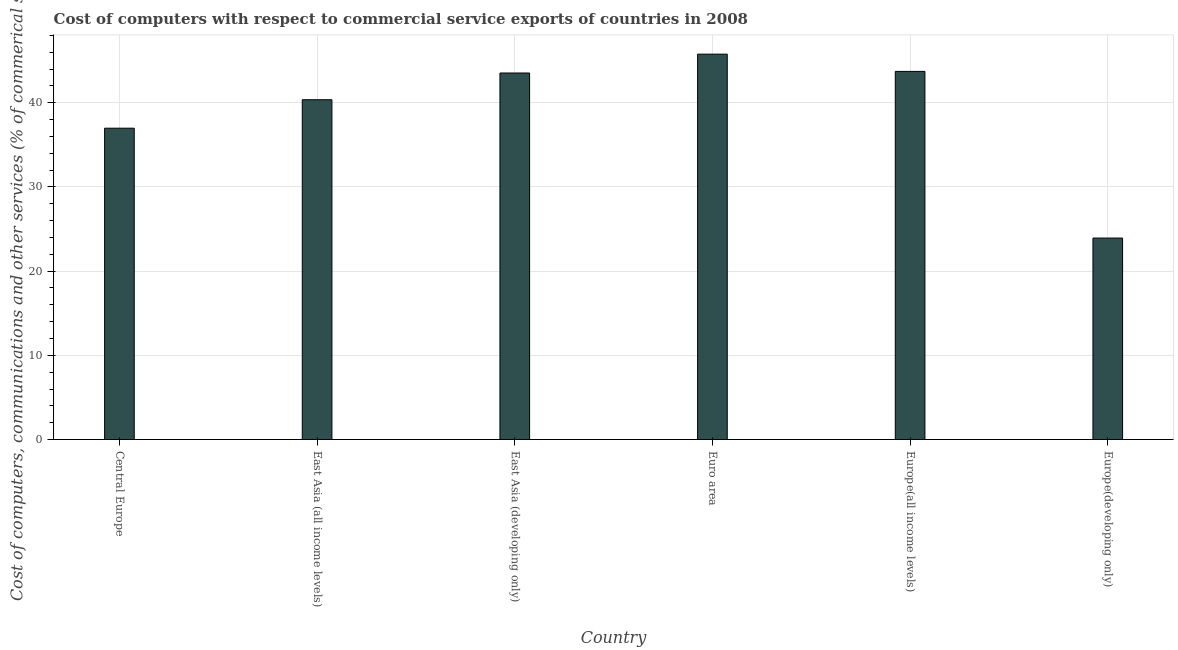Does the graph contain grids?
Give a very brief answer. Yes. What is the title of the graph?
Give a very brief answer. Cost of computers with respect to commercial service exports of countries in 2008. What is the label or title of the X-axis?
Offer a very short reply. Country. What is the label or title of the Y-axis?
Ensure brevity in your answer.  Cost of computers, communications and other services (% of commerical service exports). What is the  computer and other services in East Asia (all income levels)?
Make the answer very short. 40.36. Across all countries, what is the maximum  computer and other services?
Your answer should be very brief. 45.77. Across all countries, what is the minimum  computer and other services?
Your answer should be compact. 23.93. In which country was the cost of communications maximum?
Make the answer very short. Euro area. In which country was the cost of communications minimum?
Provide a succinct answer. Europe(developing only). What is the sum of the cost of communications?
Ensure brevity in your answer.  234.28. What is the difference between the cost of communications in Euro area and Europe(developing only)?
Your response must be concise. 21.84. What is the average  computer and other services per country?
Provide a succinct answer. 39.05. What is the median  computer and other services?
Your answer should be compact. 41.94. What is the ratio of the  computer and other services in East Asia (all income levels) to that in Europe(developing only)?
Keep it short and to the point. 1.69. Is the cost of communications in East Asia (all income levels) less than that in Europe(all income levels)?
Offer a terse response. Yes. Is the difference between the cost of communications in East Asia (all income levels) and East Asia (developing only) greater than the difference between any two countries?
Give a very brief answer. No. What is the difference between the highest and the second highest cost of communications?
Your answer should be very brief. 2.05. What is the difference between the highest and the lowest cost of communications?
Provide a short and direct response. 21.84. How many bars are there?
Keep it short and to the point. 6. Are all the bars in the graph horizontal?
Your answer should be very brief. No. How many countries are there in the graph?
Provide a short and direct response. 6. Are the values on the major ticks of Y-axis written in scientific E-notation?
Keep it short and to the point. No. What is the Cost of computers, communications and other services (% of commerical service exports) in Central Europe?
Your response must be concise. 36.98. What is the Cost of computers, communications and other services (% of commerical service exports) of East Asia (all income levels)?
Your answer should be compact. 40.36. What is the Cost of computers, communications and other services (% of commerical service exports) of East Asia (developing only)?
Your response must be concise. 43.53. What is the Cost of computers, communications and other services (% of commerical service exports) in Euro area?
Your answer should be compact. 45.77. What is the Cost of computers, communications and other services (% of commerical service exports) in Europe(all income levels)?
Make the answer very short. 43.72. What is the Cost of computers, communications and other services (% of commerical service exports) in Europe(developing only)?
Ensure brevity in your answer.  23.93. What is the difference between the Cost of computers, communications and other services (% of commerical service exports) in Central Europe and East Asia (all income levels)?
Provide a short and direct response. -3.38. What is the difference between the Cost of computers, communications and other services (% of commerical service exports) in Central Europe and East Asia (developing only)?
Your response must be concise. -6.55. What is the difference between the Cost of computers, communications and other services (% of commerical service exports) in Central Europe and Euro area?
Your answer should be very brief. -8.79. What is the difference between the Cost of computers, communications and other services (% of commerical service exports) in Central Europe and Europe(all income levels)?
Your answer should be compact. -6.75. What is the difference between the Cost of computers, communications and other services (% of commerical service exports) in Central Europe and Europe(developing only)?
Your answer should be compact. 13.05. What is the difference between the Cost of computers, communications and other services (% of commerical service exports) in East Asia (all income levels) and East Asia (developing only)?
Make the answer very short. -3.18. What is the difference between the Cost of computers, communications and other services (% of commerical service exports) in East Asia (all income levels) and Euro area?
Ensure brevity in your answer.  -5.42. What is the difference between the Cost of computers, communications and other services (% of commerical service exports) in East Asia (all income levels) and Europe(all income levels)?
Offer a very short reply. -3.37. What is the difference between the Cost of computers, communications and other services (% of commerical service exports) in East Asia (all income levels) and Europe(developing only)?
Provide a succinct answer. 16.43. What is the difference between the Cost of computers, communications and other services (% of commerical service exports) in East Asia (developing only) and Euro area?
Keep it short and to the point. -2.24. What is the difference between the Cost of computers, communications and other services (% of commerical service exports) in East Asia (developing only) and Europe(all income levels)?
Your answer should be very brief. -0.19. What is the difference between the Cost of computers, communications and other services (% of commerical service exports) in East Asia (developing only) and Europe(developing only)?
Your response must be concise. 19.6. What is the difference between the Cost of computers, communications and other services (% of commerical service exports) in Euro area and Europe(all income levels)?
Give a very brief answer. 2.05. What is the difference between the Cost of computers, communications and other services (% of commerical service exports) in Euro area and Europe(developing only)?
Offer a very short reply. 21.84. What is the difference between the Cost of computers, communications and other services (% of commerical service exports) in Europe(all income levels) and Europe(developing only)?
Your response must be concise. 19.79. What is the ratio of the Cost of computers, communications and other services (% of commerical service exports) in Central Europe to that in East Asia (all income levels)?
Ensure brevity in your answer.  0.92. What is the ratio of the Cost of computers, communications and other services (% of commerical service exports) in Central Europe to that in East Asia (developing only)?
Keep it short and to the point. 0.85. What is the ratio of the Cost of computers, communications and other services (% of commerical service exports) in Central Europe to that in Euro area?
Your answer should be very brief. 0.81. What is the ratio of the Cost of computers, communications and other services (% of commerical service exports) in Central Europe to that in Europe(all income levels)?
Your answer should be compact. 0.85. What is the ratio of the Cost of computers, communications and other services (% of commerical service exports) in Central Europe to that in Europe(developing only)?
Your answer should be compact. 1.54. What is the ratio of the Cost of computers, communications and other services (% of commerical service exports) in East Asia (all income levels) to that in East Asia (developing only)?
Make the answer very short. 0.93. What is the ratio of the Cost of computers, communications and other services (% of commerical service exports) in East Asia (all income levels) to that in Euro area?
Your answer should be very brief. 0.88. What is the ratio of the Cost of computers, communications and other services (% of commerical service exports) in East Asia (all income levels) to that in Europe(all income levels)?
Ensure brevity in your answer.  0.92. What is the ratio of the Cost of computers, communications and other services (% of commerical service exports) in East Asia (all income levels) to that in Europe(developing only)?
Provide a short and direct response. 1.69. What is the ratio of the Cost of computers, communications and other services (% of commerical service exports) in East Asia (developing only) to that in Euro area?
Ensure brevity in your answer.  0.95. What is the ratio of the Cost of computers, communications and other services (% of commerical service exports) in East Asia (developing only) to that in Europe(developing only)?
Keep it short and to the point. 1.82. What is the ratio of the Cost of computers, communications and other services (% of commerical service exports) in Euro area to that in Europe(all income levels)?
Offer a very short reply. 1.05. What is the ratio of the Cost of computers, communications and other services (% of commerical service exports) in Euro area to that in Europe(developing only)?
Offer a terse response. 1.91. What is the ratio of the Cost of computers, communications and other services (% of commerical service exports) in Europe(all income levels) to that in Europe(developing only)?
Make the answer very short. 1.83. 